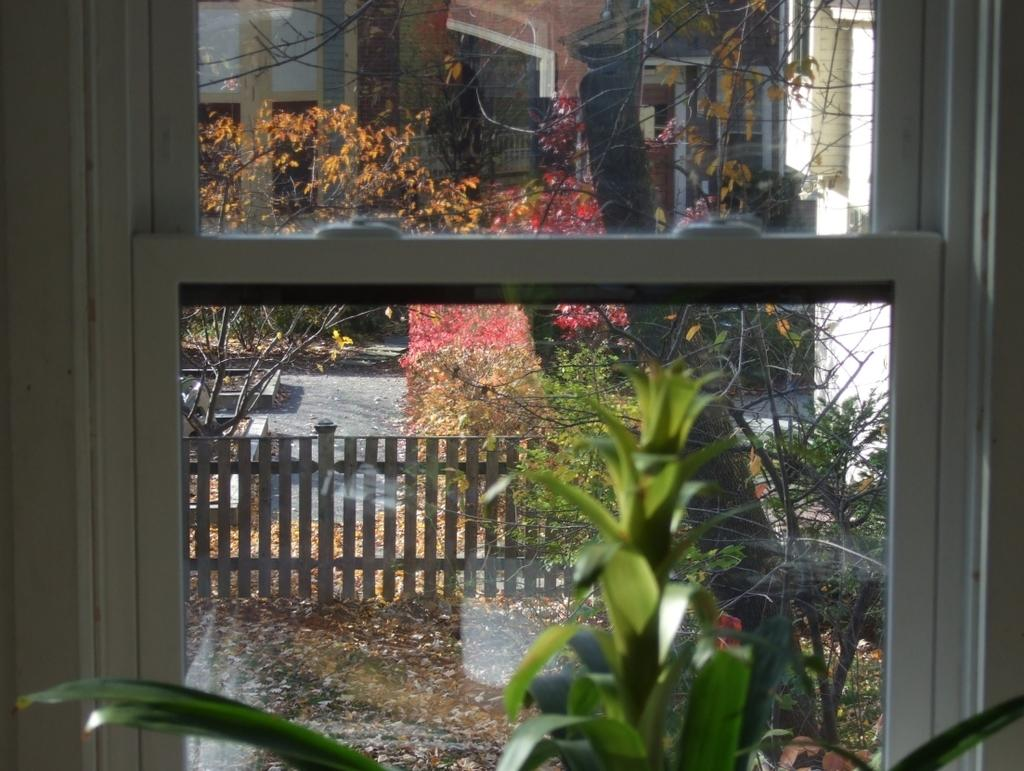What can be seen through the window in the image? The railing, trees, and a building are visible through the window in the image. What is located in front of the window? There is a plant in front of the window. Can you describe the view through the window? The view through the window includes a railing, trees, and a building. What type of cork can be seen in the image? There is no cork present in the image. How many turkeys are visible through the window in the image? There are no turkeys visible through the window in the image. 